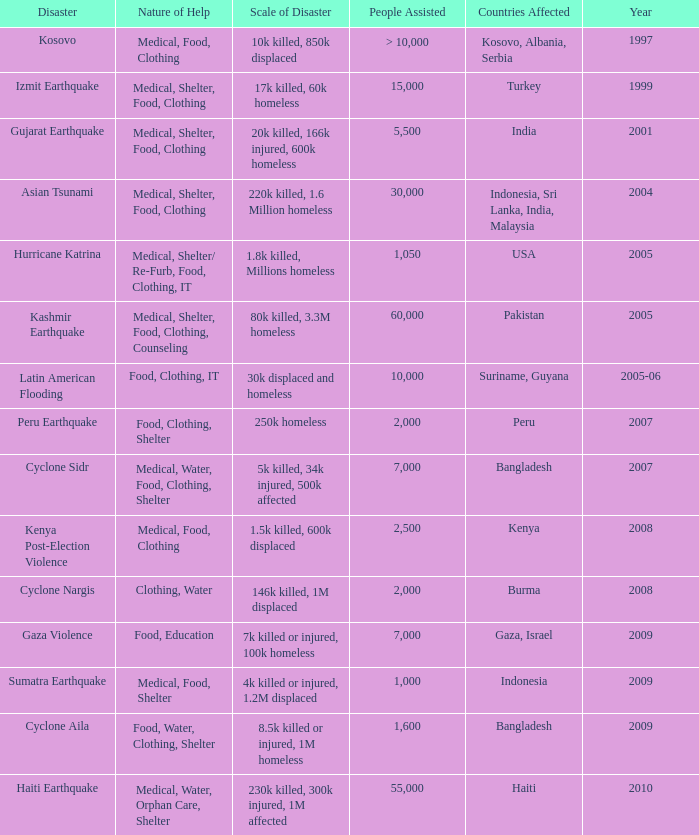How many people were assisted in 1997? > 10,000. 